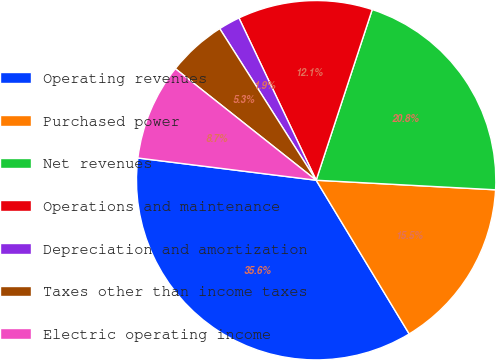Convert chart. <chart><loc_0><loc_0><loc_500><loc_500><pie_chart><fcel>Operating revenues<fcel>Purchased power<fcel>Net revenues<fcel>Operations and maintenance<fcel>Depreciation and amortization<fcel>Taxes other than income taxes<fcel>Electric operating income<nl><fcel>35.64%<fcel>15.49%<fcel>20.8%<fcel>12.12%<fcel>1.95%<fcel>5.32%<fcel>8.69%<nl></chart> 